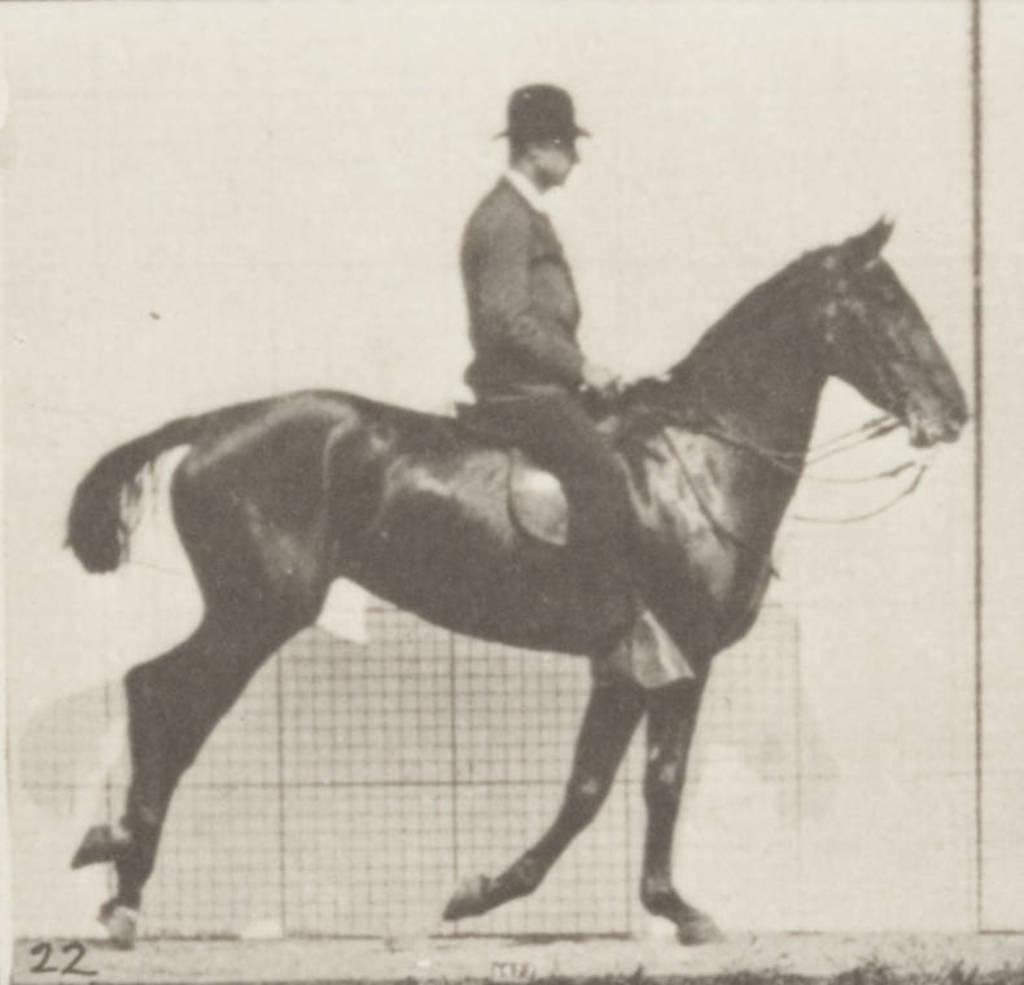What animal can be seen in the image? There is a horse in the image. What is the man in the image doing? A man is riding the horse in the image. How is the man controlling the horse? The man is holding a rope attached to the horse. What type of headwear is the man wearing? The man is wearing a cap. Can you describe any additional details about the photo frame? The number "22" is written in the left side corner of the photo frame. What is the man's annual income in the image? There is no information about the man's income in the image. How does the horse turn around in the image? The horse does not turn around in the image; it is moving forward with the man riding it. 